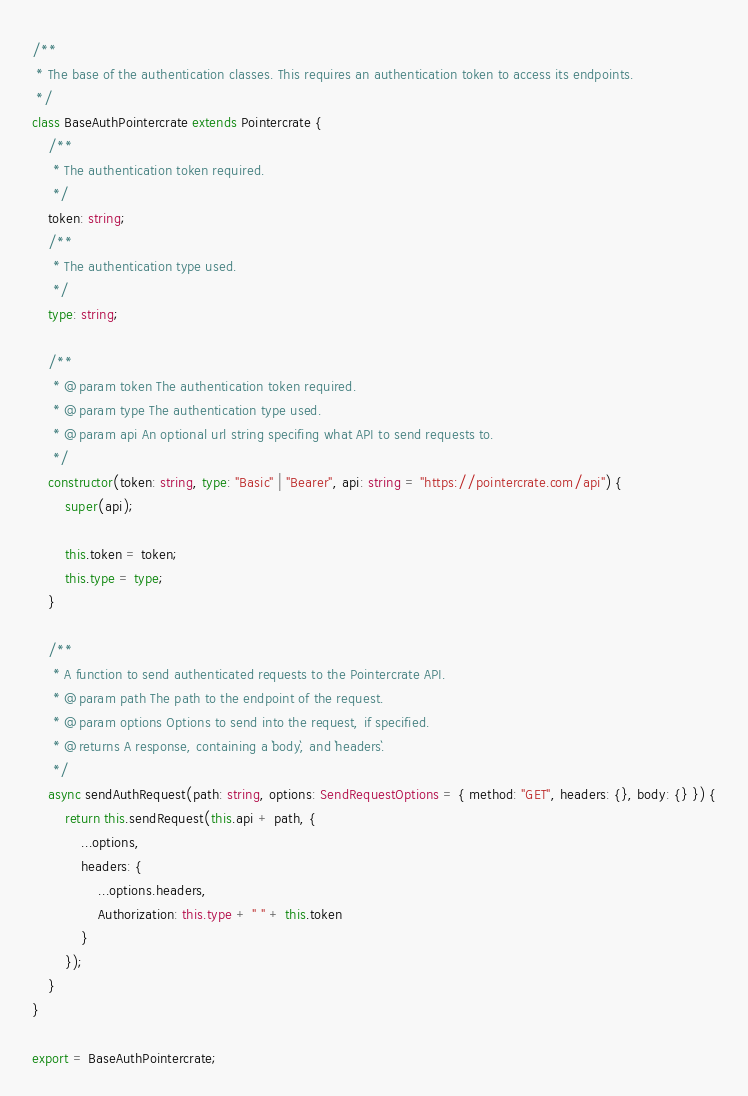Convert code to text. <code><loc_0><loc_0><loc_500><loc_500><_TypeScript_>
/**
 * The base of the authentication classes. This requires an authentication token to access its endpoints.
 */
class BaseAuthPointercrate extends Pointercrate {
    /**
     * The authentication token required.
     */
    token: string;
    /**
     * The authentication type used.
     */
    type: string;
    
    /**
     * @param token The authentication token required.
     * @param type The authentication type used.
     * @param api An optional url string specifing what API to send requests to.
     */
    constructor(token: string, type: "Basic" | "Bearer", api: string = "https://pointercrate.com/api") {
        super(api);

        this.token = token;
        this.type = type;
    }

    /**
     * A function to send authenticated requests to the Pointercrate API.
     * @param path The path to the endpoint of the request.
     * @param options Options to send into the request, if specified.
     * @returns A response, containing a `body`, and `headers`.
     */
    async sendAuthRequest(path: string, options: SendRequestOptions = { method: "GET", headers: {}, body: {} }) {
        return this.sendRequest(this.api + path, {
            ...options,
            headers: {
                ...options.headers,
                Authorization: this.type + " " + this.token
            }
        });
    }
}

export = BaseAuthPointercrate;</code> 